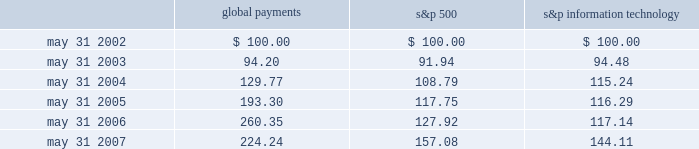Stock performance graph the following line-graph presentation compares our cumulative shareholder returns with the standard & poor 2019s information technology index and the standard & poor 2019s 500 stock index for the past five years .
The line graph assumes the investment of $ 100 in our common stock , the standard & poor 2019s information technology index , and the standard & poor 2019s 500 stock index on may 31 , 2002 and assumes reinvestment of all dividends .
Comparison of 5 year cumulative total return* among global payments inc. , the s&p 500 index and the s&p information technology index 5/02 5/03 5/04 5/05 5/06 5/07 global payments inc .
S&p 500 s&p information technology * $ 100 invested on 5/31/02 in stock or index-including reinvestment of dividends .
Fiscal year ending may 31 .
Global payments s&p 500 information technology .
Issuer purchases of equity securities on april 5 , 2007 , our board of directors authorized repurchases of our common stock in an amount up to $ 100 million .
The board has authorized us to purchase shares from time to time as market conditions permit .
There is no expiration date with respect to this authorization .
No amounts have been repurchased during the fiscal year ended may 31 , 2007. .
In comparison to overall information technology sector , how much percentage would global payments have earned the investor .? 
Rationale: to calculate how much greater the return was for global payments , one must find the percentage gain of the s&p information technology and global payments . then one must subtract these two percentages to find the change between the two .
Computations: ((224.24 - 100) - (144.11 - 100))
Answer: 80.13. 